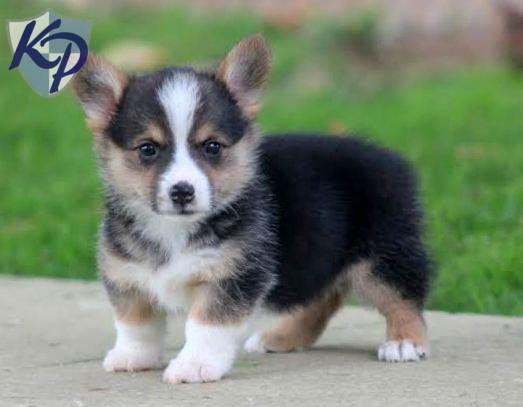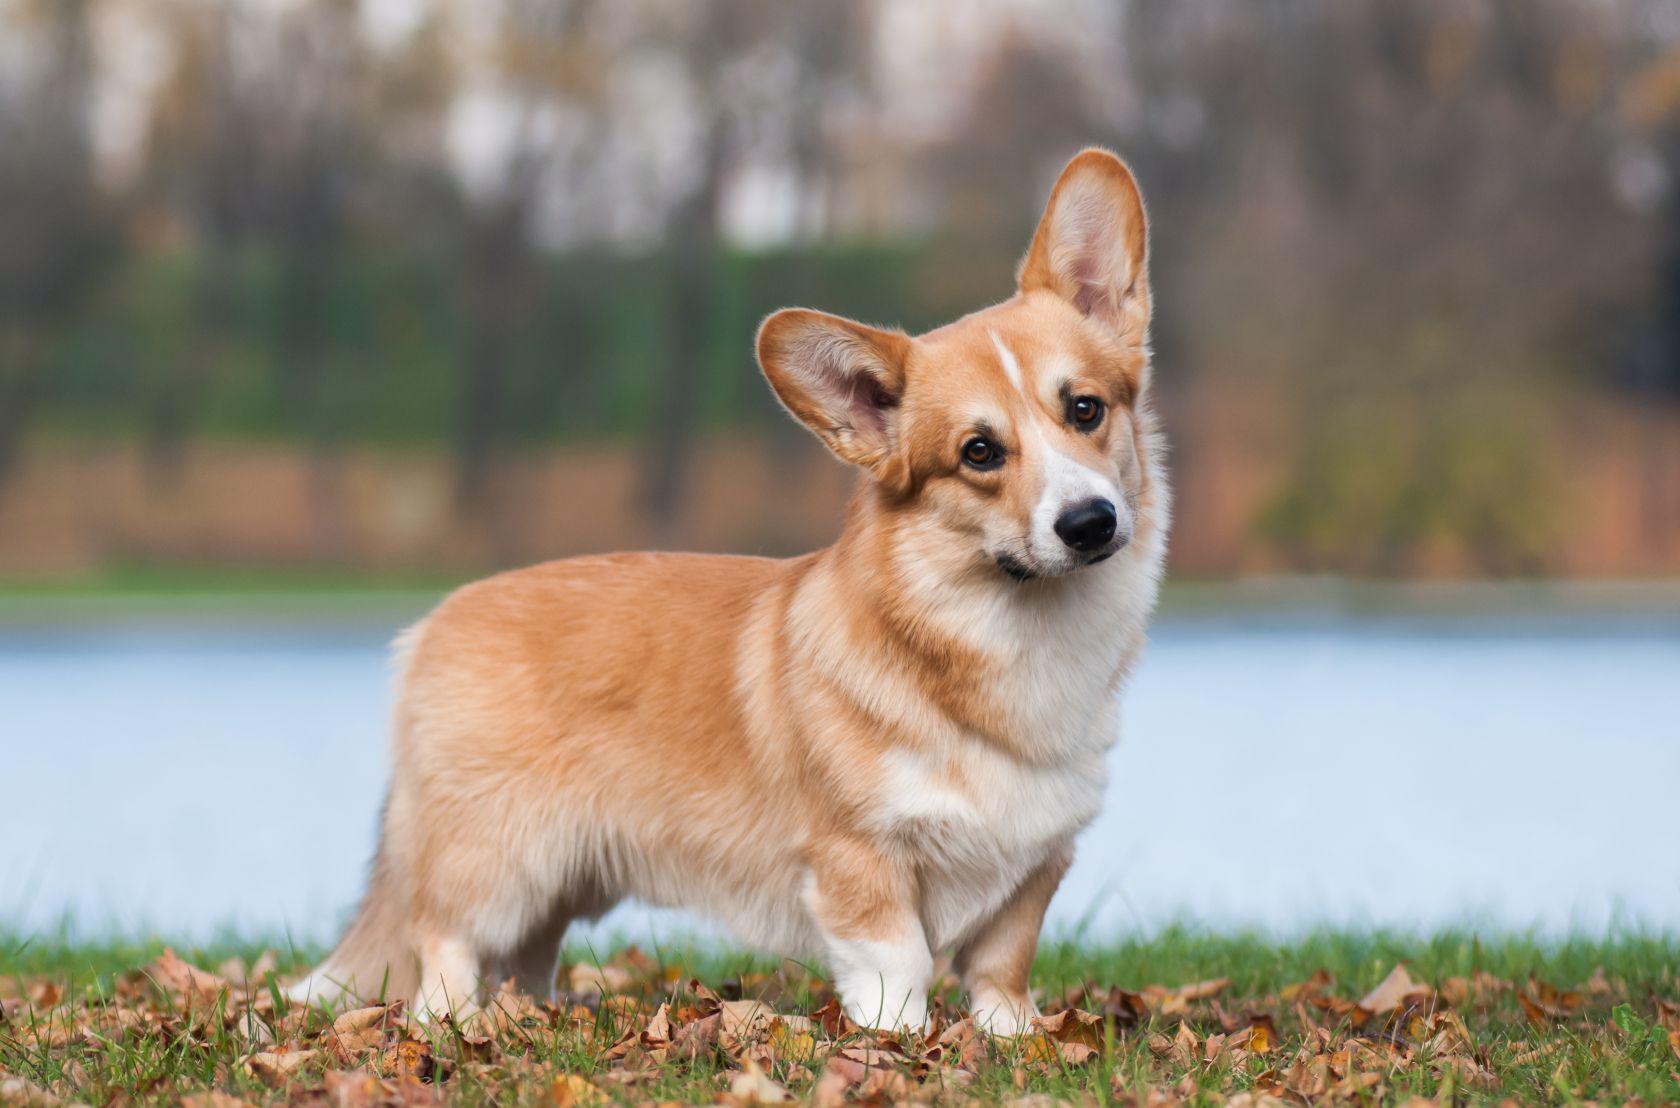The first image is the image on the left, the second image is the image on the right. Analyze the images presented: Is the assertion "There are at least three Corgis in the image." valid? Answer yes or no. No. 